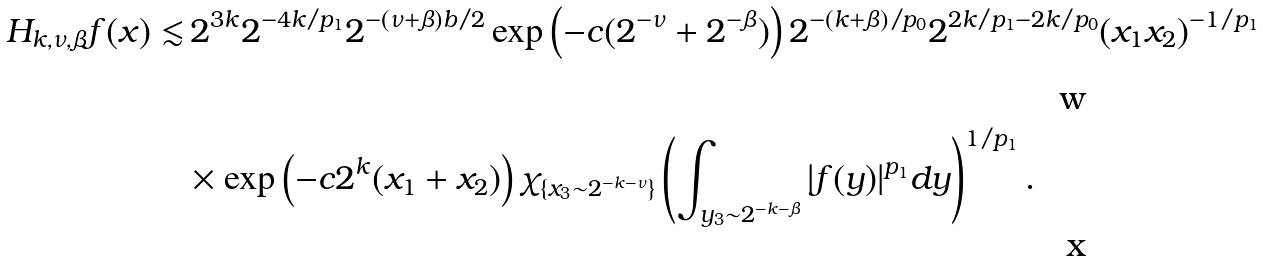Convert formula to latex. <formula><loc_0><loc_0><loc_500><loc_500>H _ { k , \nu , \beta } f ( x ) \lesssim & \, 2 ^ { 3 k } 2 ^ { - 4 k \slash p _ { 1 } } 2 ^ { - ( \nu + \beta ) b \slash 2 } \exp \left ( - c ( 2 ^ { - \nu } + 2 ^ { - \beta } ) \right ) 2 ^ { - ( k + \beta ) \slash p _ { 0 } } 2 ^ { 2 k \slash p _ { 1 } - 2 k \slash p _ { 0 } } ( x _ { 1 } x _ { 2 } ) ^ { - 1 \slash p _ { 1 } } \\ & \times \exp \left ( - c 2 ^ { k } ( x _ { 1 } + x _ { 2 } ) \right ) \chi _ { \{ x _ { 3 } \sim 2 ^ { - k - \nu } \} } \left ( \int _ { y _ { 3 } \sim 2 ^ { - k - \beta } } | f ( y ) | ^ { p _ { 1 } } d y \right ) ^ { 1 \slash p _ { 1 } } .</formula> 